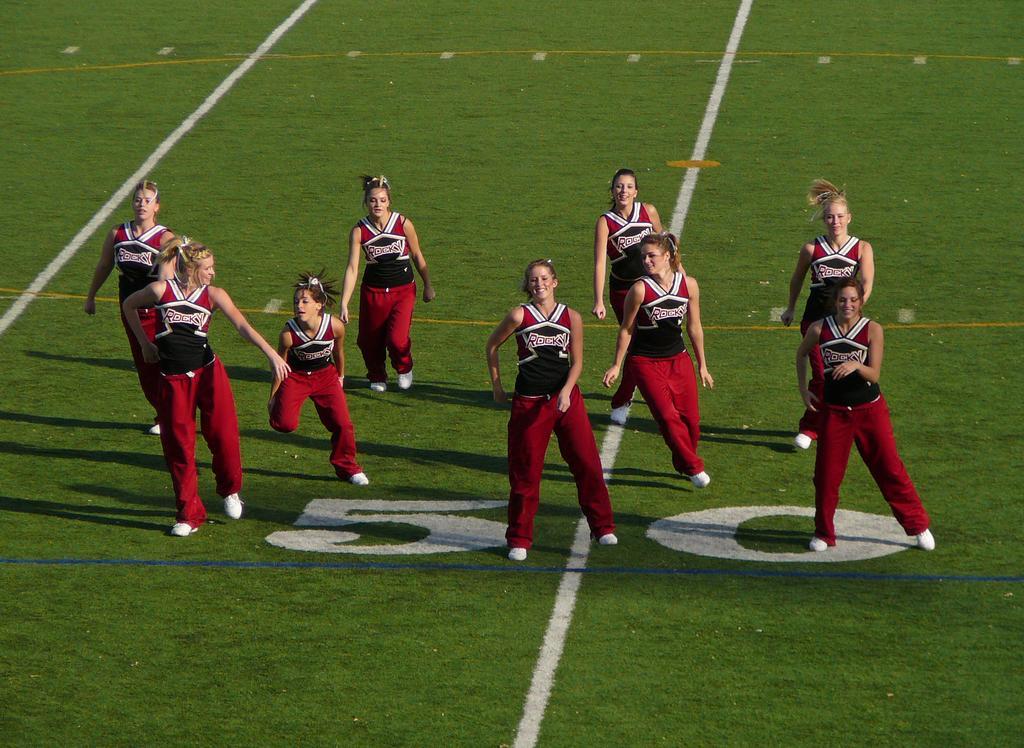Could you give a brief overview of what you see in this image? In this image in the center there are a group of people, and it seems that they are dancing. At the bottom there is ground. 